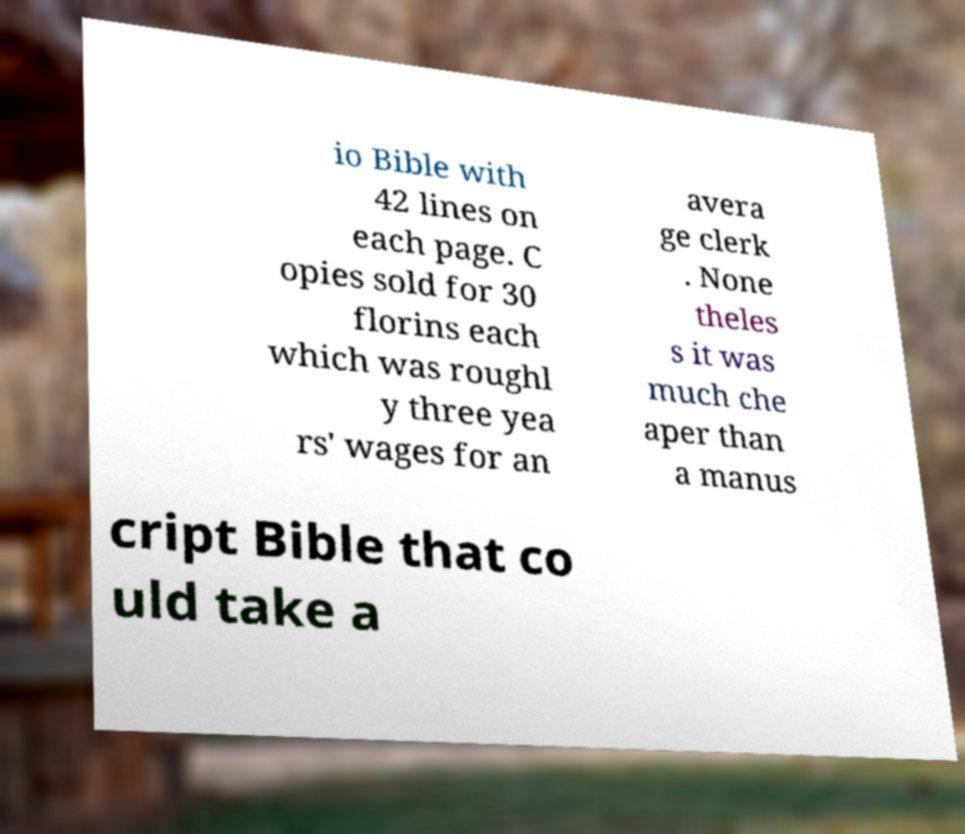Can you read and provide the text displayed in the image?This photo seems to have some interesting text. Can you extract and type it out for me? io Bible with 42 lines on each page. C opies sold for 30 florins each which was roughl y three yea rs' wages for an avera ge clerk . None theles s it was much che aper than a manus cript Bible that co uld take a 